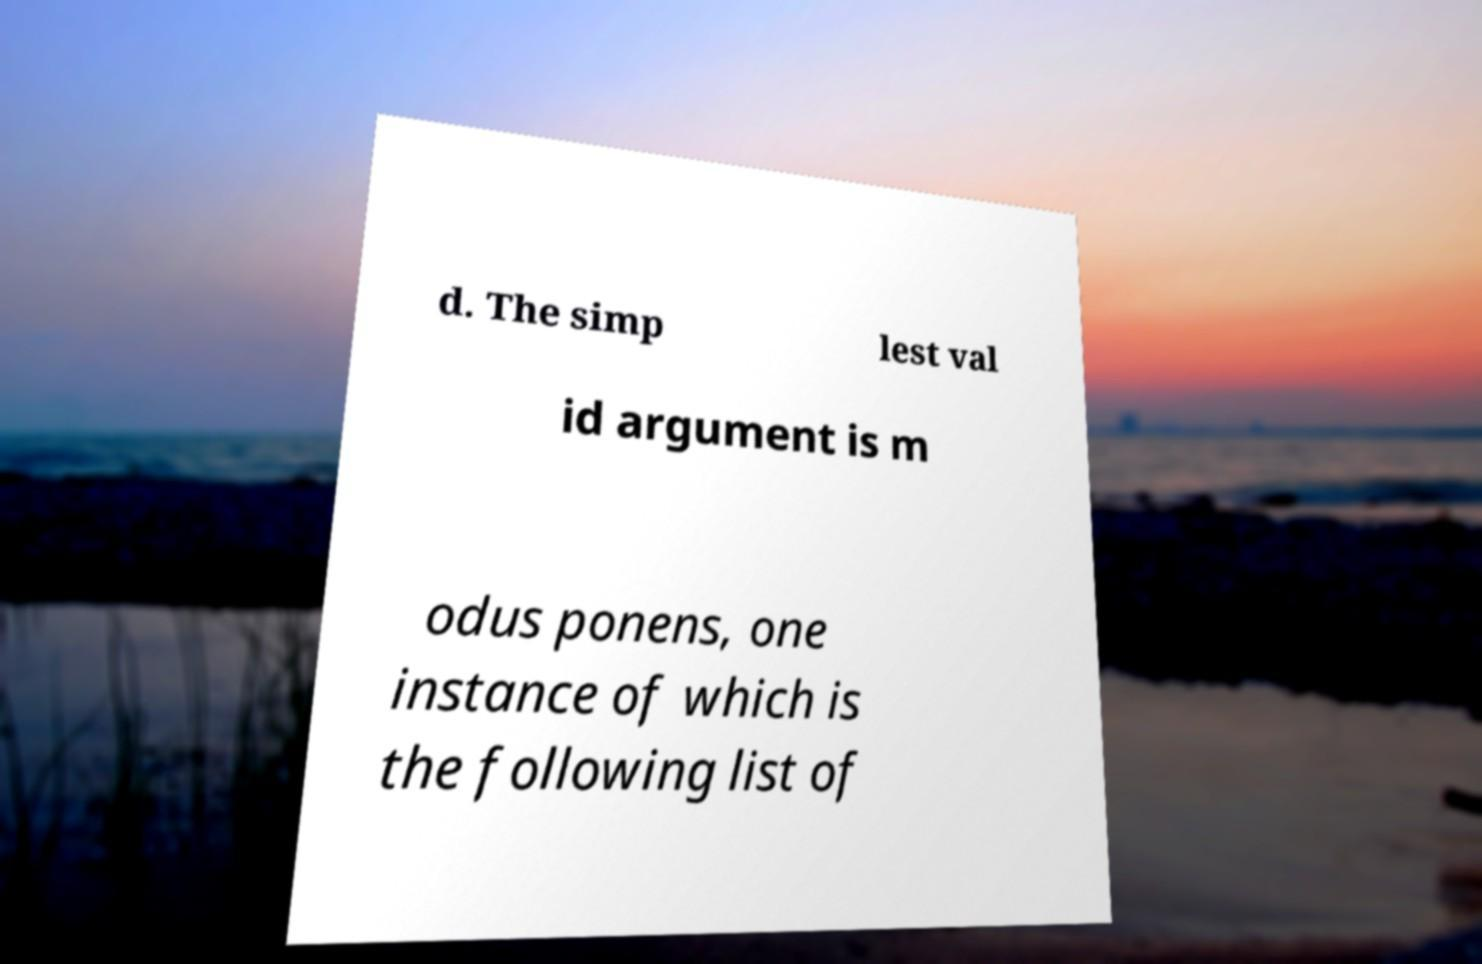For documentation purposes, I need the text within this image transcribed. Could you provide that? d. The simp lest val id argument is m odus ponens, one instance of which is the following list of 